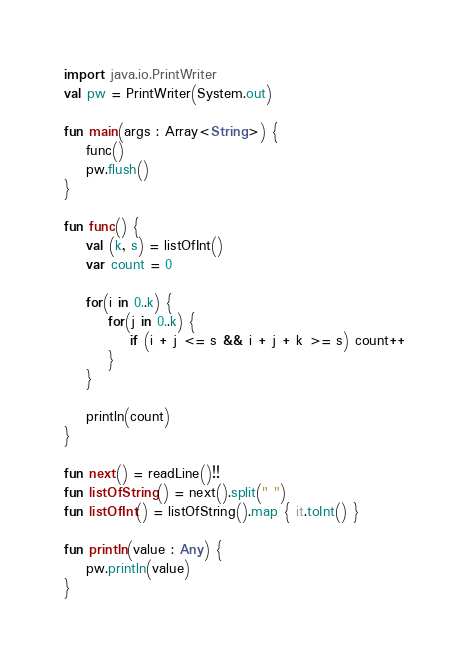Convert code to text. <code><loc_0><loc_0><loc_500><loc_500><_Kotlin_>import java.io.PrintWriter
val pw = PrintWriter(System.out)

fun main(args : Array<String>) {
    func()
    pw.flush()
}

fun func() {
    val (k, s) = listOfInt()
    var count = 0

    for(i in 0..k) {
        for(j in 0..k) {
            if (i + j <= s && i + j + k >= s) count++
        }
    }

    println(count)
}

fun next() = readLine()!!
fun listOfString() = next().split(" ")
fun listOfInt() = listOfString().map { it.toInt() }

fun println(value : Any) {
    pw.println(value)
}</code> 